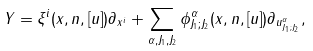Convert formula to latex. <formula><loc_0><loc_0><loc_500><loc_500>Y = \xi ^ { i } ( x , n , [ u ] ) \partial _ { x ^ { i } } + \sum _ { \alpha , J _ { 1 } , J _ { 2 } } \phi ^ { \alpha } _ { J _ { 1 } ; J _ { 2 } } ( x , n , [ u ] ) \partial _ { u ^ { \alpha } _ { J _ { 1 } ; J _ { 2 } } } ,</formula> 